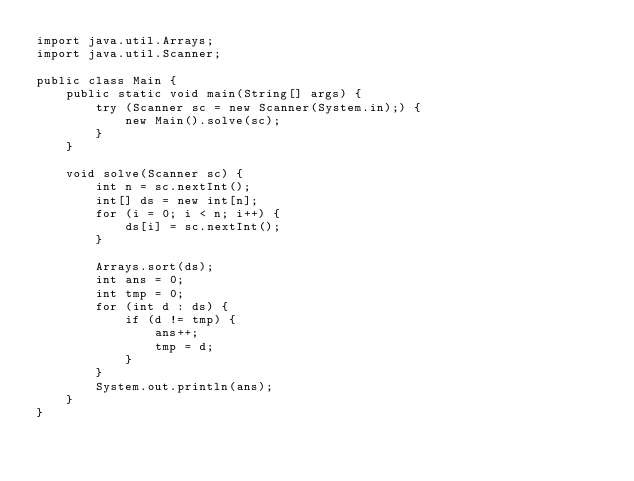Convert code to text. <code><loc_0><loc_0><loc_500><loc_500><_Java_>import java.util.Arrays;
import java.util.Scanner;

public class Main {
    public static void main(String[] args) {
        try (Scanner sc = new Scanner(System.in);) {
            new Main().solve(sc);
        }
    }

    void solve(Scanner sc) {
        int n = sc.nextInt();
        int[] ds = new int[n];
        for (i = 0; i < n; i++) {
            ds[i] = sc.nextInt();
        }

        Arrays.sort(ds);
        int ans = 0;
        int tmp = 0;
        for (int d : ds) {
            if (d != tmp) {
                ans++;
                tmp = d;
            }
        }
        System.out.println(ans);
    }
}</code> 